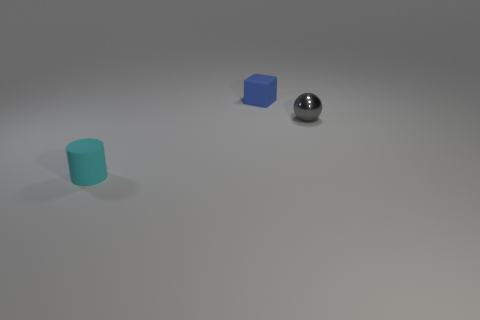Add 2 big purple cubes. How many objects exist? 5 Subtract all cylinders. How many objects are left? 2 Subtract all brown spheres. Subtract all purple cylinders. How many spheres are left? 1 Subtract all blue matte blocks. Subtract all small gray metallic objects. How many objects are left? 1 Add 1 blue matte things. How many blue matte things are left? 2 Add 1 shiny balls. How many shiny balls exist? 2 Subtract 0 gray cylinders. How many objects are left? 3 Subtract 1 cubes. How many cubes are left? 0 